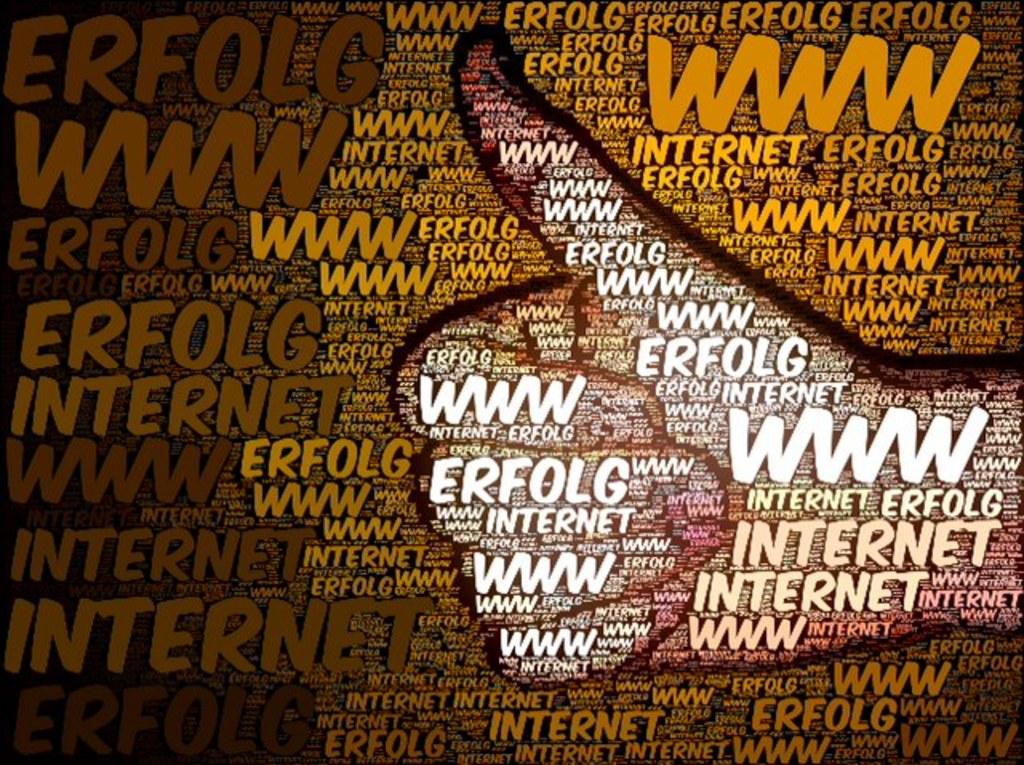What website is advertised?
Provide a succinct answer. Erfolg. 